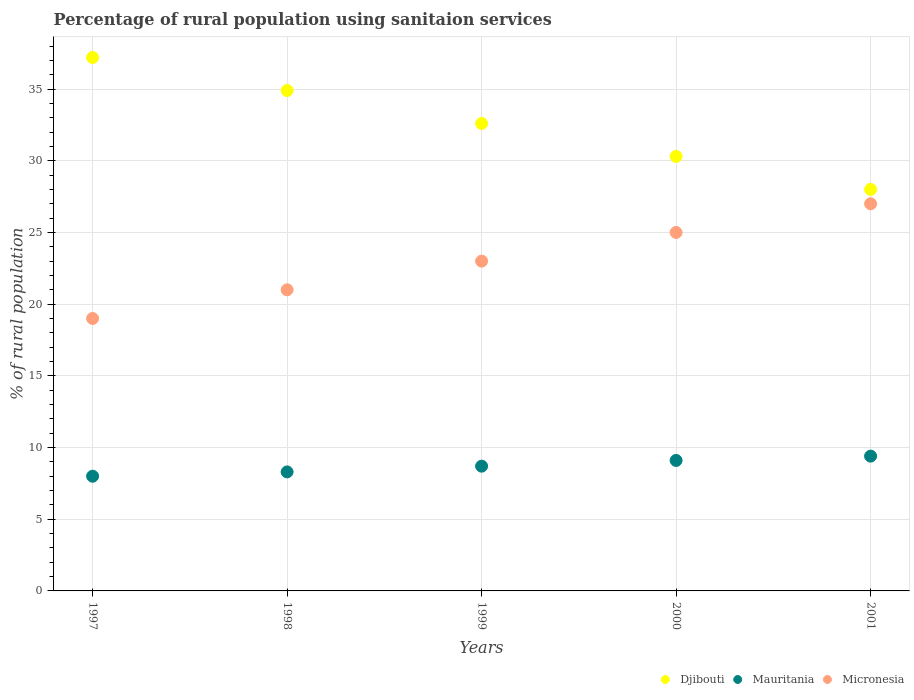Across all years, what is the maximum percentage of rural population using sanitaion services in Djibouti?
Provide a succinct answer. 37.2. Across all years, what is the minimum percentage of rural population using sanitaion services in Mauritania?
Provide a succinct answer. 8. In which year was the percentage of rural population using sanitaion services in Micronesia maximum?
Your response must be concise. 2001. What is the total percentage of rural population using sanitaion services in Djibouti in the graph?
Your response must be concise. 163. What is the difference between the percentage of rural population using sanitaion services in Djibouti in 1997 and that in 1998?
Offer a terse response. 2.3. What is the difference between the percentage of rural population using sanitaion services in Micronesia in 2001 and the percentage of rural population using sanitaion services in Mauritania in 2000?
Provide a short and direct response. 17.9. What is the average percentage of rural population using sanitaion services in Djibouti per year?
Give a very brief answer. 32.6. In the year 1998, what is the difference between the percentage of rural population using sanitaion services in Djibouti and percentage of rural population using sanitaion services in Mauritania?
Make the answer very short. 26.6. What is the ratio of the percentage of rural population using sanitaion services in Micronesia in 1997 to that in 1998?
Your answer should be very brief. 0.9. Is the percentage of rural population using sanitaion services in Mauritania in 1997 less than that in 1998?
Provide a short and direct response. Yes. Is the difference between the percentage of rural population using sanitaion services in Djibouti in 2000 and 2001 greater than the difference between the percentage of rural population using sanitaion services in Mauritania in 2000 and 2001?
Your answer should be compact. Yes. What is the difference between the highest and the second highest percentage of rural population using sanitaion services in Djibouti?
Ensure brevity in your answer.  2.3. What is the difference between the highest and the lowest percentage of rural population using sanitaion services in Micronesia?
Your response must be concise. 8. In how many years, is the percentage of rural population using sanitaion services in Mauritania greater than the average percentage of rural population using sanitaion services in Mauritania taken over all years?
Offer a terse response. 2. Is the sum of the percentage of rural population using sanitaion services in Micronesia in 2000 and 2001 greater than the maximum percentage of rural population using sanitaion services in Mauritania across all years?
Offer a terse response. Yes. Is it the case that in every year, the sum of the percentage of rural population using sanitaion services in Micronesia and percentage of rural population using sanitaion services in Djibouti  is greater than the percentage of rural population using sanitaion services in Mauritania?
Your response must be concise. Yes. How many dotlines are there?
Provide a succinct answer. 3. What is the difference between two consecutive major ticks on the Y-axis?
Provide a short and direct response. 5. Does the graph contain grids?
Offer a terse response. Yes. Where does the legend appear in the graph?
Your answer should be very brief. Bottom right. What is the title of the graph?
Ensure brevity in your answer.  Percentage of rural population using sanitaion services. Does "Uruguay" appear as one of the legend labels in the graph?
Offer a terse response. No. What is the label or title of the Y-axis?
Ensure brevity in your answer.  % of rural population. What is the % of rural population in Djibouti in 1997?
Your response must be concise. 37.2. What is the % of rural population of Djibouti in 1998?
Give a very brief answer. 34.9. What is the % of rural population in Djibouti in 1999?
Ensure brevity in your answer.  32.6. What is the % of rural population of Djibouti in 2000?
Make the answer very short. 30.3. What is the % of rural population of Micronesia in 2000?
Ensure brevity in your answer.  25. What is the % of rural population of Djibouti in 2001?
Offer a very short reply. 28. What is the % of rural population in Mauritania in 2001?
Give a very brief answer. 9.4. What is the % of rural population in Micronesia in 2001?
Make the answer very short. 27. Across all years, what is the maximum % of rural population in Djibouti?
Provide a succinct answer. 37.2. Across all years, what is the maximum % of rural population of Micronesia?
Your answer should be very brief. 27. What is the total % of rural population of Djibouti in the graph?
Your answer should be very brief. 163. What is the total % of rural population in Mauritania in the graph?
Ensure brevity in your answer.  43.5. What is the total % of rural population of Micronesia in the graph?
Offer a terse response. 115. What is the difference between the % of rural population in Djibouti in 1997 and that in 1998?
Your answer should be very brief. 2.3. What is the difference between the % of rural population of Micronesia in 1997 and that in 1998?
Provide a short and direct response. -2. What is the difference between the % of rural population of Mauritania in 1997 and that in 1999?
Keep it short and to the point. -0.7. What is the difference between the % of rural population of Mauritania in 1997 and that in 2000?
Provide a short and direct response. -1.1. What is the difference between the % of rural population of Micronesia in 1997 and that in 2000?
Provide a succinct answer. -6. What is the difference between the % of rural population in Mauritania in 1997 and that in 2001?
Your answer should be very brief. -1.4. What is the difference between the % of rural population in Djibouti in 1998 and that in 1999?
Offer a very short reply. 2.3. What is the difference between the % of rural population of Mauritania in 1998 and that in 1999?
Give a very brief answer. -0.4. What is the difference between the % of rural population in Micronesia in 1998 and that in 1999?
Offer a terse response. -2. What is the difference between the % of rural population of Mauritania in 1998 and that in 2000?
Give a very brief answer. -0.8. What is the difference between the % of rural population in Djibouti in 1998 and that in 2001?
Give a very brief answer. 6.9. What is the difference between the % of rural population in Djibouti in 1999 and that in 2000?
Offer a very short reply. 2.3. What is the difference between the % of rural population of Micronesia in 1999 and that in 2000?
Your answer should be very brief. -2. What is the difference between the % of rural population in Mauritania in 2000 and that in 2001?
Your response must be concise. -0.3. What is the difference between the % of rural population in Micronesia in 2000 and that in 2001?
Provide a short and direct response. -2. What is the difference between the % of rural population in Djibouti in 1997 and the % of rural population in Mauritania in 1998?
Keep it short and to the point. 28.9. What is the difference between the % of rural population of Mauritania in 1997 and the % of rural population of Micronesia in 1998?
Your answer should be very brief. -13. What is the difference between the % of rural population in Djibouti in 1997 and the % of rural population in Mauritania in 2000?
Offer a very short reply. 28.1. What is the difference between the % of rural population of Mauritania in 1997 and the % of rural population of Micronesia in 2000?
Your answer should be compact. -17. What is the difference between the % of rural population in Djibouti in 1997 and the % of rural population in Mauritania in 2001?
Provide a short and direct response. 27.8. What is the difference between the % of rural population of Mauritania in 1997 and the % of rural population of Micronesia in 2001?
Keep it short and to the point. -19. What is the difference between the % of rural population in Djibouti in 1998 and the % of rural population in Mauritania in 1999?
Provide a short and direct response. 26.2. What is the difference between the % of rural population in Mauritania in 1998 and the % of rural population in Micronesia in 1999?
Make the answer very short. -14.7. What is the difference between the % of rural population in Djibouti in 1998 and the % of rural population in Mauritania in 2000?
Your answer should be compact. 25.8. What is the difference between the % of rural population in Djibouti in 1998 and the % of rural population in Micronesia in 2000?
Give a very brief answer. 9.9. What is the difference between the % of rural population in Mauritania in 1998 and the % of rural population in Micronesia in 2000?
Your answer should be compact. -16.7. What is the difference between the % of rural population in Mauritania in 1998 and the % of rural population in Micronesia in 2001?
Provide a short and direct response. -18.7. What is the difference between the % of rural population of Mauritania in 1999 and the % of rural population of Micronesia in 2000?
Your answer should be very brief. -16.3. What is the difference between the % of rural population in Djibouti in 1999 and the % of rural population in Mauritania in 2001?
Your answer should be compact. 23.2. What is the difference between the % of rural population in Mauritania in 1999 and the % of rural population in Micronesia in 2001?
Offer a terse response. -18.3. What is the difference between the % of rural population of Djibouti in 2000 and the % of rural population of Mauritania in 2001?
Offer a terse response. 20.9. What is the difference between the % of rural population of Djibouti in 2000 and the % of rural population of Micronesia in 2001?
Provide a succinct answer. 3.3. What is the difference between the % of rural population in Mauritania in 2000 and the % of rural population in Micronesia in 2001?
Provide a succinct answer. -17.9. What is the average % of rural population of Djibouti per year?
Provide a short and direct response. 32.6. What is the average % of rural population in Mauritania per year?
Provide a short and direct response. 8.7. What is the average % of rural population in Micronesia per year?
Offer a very short reply. 23. In the year 1997, what is the difference between the % of rural population in Djibouti and % of rural population in Mauritania?
Offer a very short reply. 29.2. In the year 1997, what is the difference between the % of rural population of Mauritania and % of rural population of Micronesia?
Provide a succinct answer. -11. In the year 1998, what is the difference between the % of rural population in Djibouti and % of rural population in Mauritania?
Provide a succinct answer. 26.6. In the year 1998, what is the difference between the % of rural population of Djibouti and % of rural population of Micronesia?
Keep it short and to the point. 13.9. In the year 1999, what is the difference between the % of rural population in Djibouti and % of rural population in Mauritania?
Provide a short and direct response. 23.9. In the year 1999, what is the difference between the % of rural population in Djibouti and % of rural population in Micronesia?
Offer a terse response. 9.6. In the year 1999, what is the difference between the % of rural population of Mauritania and % of rural population of Micronesia?
Your answer should be very brief. -14.3. In the year 2000, what is the difference between the % of rural population in Djibouti and % of rural population in Mauritania?
Offer a terse response. 21.2. In the year 2000, what is the difference between the % of rural population in Mauritania and % of rural population in Micronesia?
Your answer should be very brief. -15.9. In the year 2001, what is the difference between the % of rural population of Djibouti and % of rural population of Mauritania?
Your answer should be compact. 18.6. In the year 2001, what is the difference between the % of rural population of Djibouti and % of rural population of Micronesia?
Provide a short and direct response. 1. In the year 2001, what is the difference between the % of rural population in Mauritania and % of rural population in Micronesia?
Your answer should be very brief. -17.6. What is the ratio of the % of rural population in Djibouti in 1997 to that in 1998?
Give a very brief answer. 1.07. What is the ratio of the % of rural population in Mauritania in 1997 to that in 1998?
Keep it short and to the point. 0.96. What is the ratio of the % of rural population in Micronesia in 1997 to that in 1998?
Provide a succinct answer. 0.9. What is the ratio of the % of rural population of Djibouti in 1997 to that in 1999?
Provide a short and direct response. 1.14. What is the ratio of the % of rural population in Mauritania in 1997 to that in 1999?
Your answer should be compact. 0.92. What is the ratio of the % of rural population of Micronesia in 1997 to that in 1999?
Your answer should be very brief. 0.83. What is the ratio of the % of rural population in Djibouti in 1997 to that in 2000?
Keep it short and to the point. 1.23. What is the ratio of the % of rural population in Mauritania in 1997 to that in 2000?
Provide a short and direct response. 0.88. What is the ratio of the % of rural population in Micronesia in 1997 to that in 2000?
Offer a terse response. 0.76. What is the ratio of the % of rural population in Djibouti in 1997 to that in 2001?
Your answer should be very brief. 1.33. What is the ratio of the % of rural population of Mauritania in 1997 to that in 2001?
Provide a short and direct response. 0.85. What is the ratio of the % of rural population in Micronesia in 1997 to that in 2001?
Give a very brief answer. 0.7. What is the ratio of the % of rural population of Djibouti in 1998 to that in 1999?
Offer a very short reply. 1.07. What is the ratio of the % of rural population in Mauritania in 1998 to that in 1999?
Give a very brief answer. 0.95. What is the ratio of the % of rural population of Micronesia in 1998 to that in 1999?
Provide a short and direct response. 0.91. What is the ratio of the % of rural population of Djibouti in 1998 to that in 2000?
Give a very brief answer. 1.15. What is the ratio of the % of rural population in Mauritania in 1998 to that in 2000?
Provide a succinct answer. 0.91. What is the ratio of the % of rural population of Micronesia in 1998 to that in 2000?
Your answer should be very brief. 0.84. What is the ratio of the % of rural population in Djibouti in 1998 to that in 2001?
Provide a short and direct response. 1.25. What is the ratio of the % of rural population in Mauritania in 1998 to that in 2001?
Your response must be concise. 0.88. What is the ratio of the % of rural population of Djibouti in 1999 to that in 2000?
Provide a succinct answer. 1.08. What is the ratio of the % of rural population in Mauritania in 1999 to that in 2000?
Ensure brevity in your answer.  0.96. What is the ratio of the % of rural population in Micronesia in 1999 to that in 2000?
Give a very brief answer. 0.92. What is the ratio of the % of rural population of Djibouti in 1999 to that in 2001?
Your answer should be compact. 1.16. What is the ratio of the % of rural population of Mauritania in 1999 to that in 2001?
Provide a short and direct response. 0.93. What is the ratio of the % of rural population in Micronesia in 1999 to that in 2001?
Your answer should be compact. 0.85. What is the ratio of the % of rural population in Djibouti in 2000 to that in 2001?
Provide a succinct answer. 1.08. What is the ratio of the % of rural population in Mauritania in 2000 to that in 2001?
Provide a short and direct response. 0.97. What is the ratio of the % of rural population in Micronesia in 2000 to that in 2001?
Your answer should be compact. 0.93. What is the difference between the highest and the lowest % of rural population in Mauritania?
Make the answer very short. 1.4. What is the difference between the highest and the lowest % of rural population of Micronesia?
Make the answer very short. 8. 